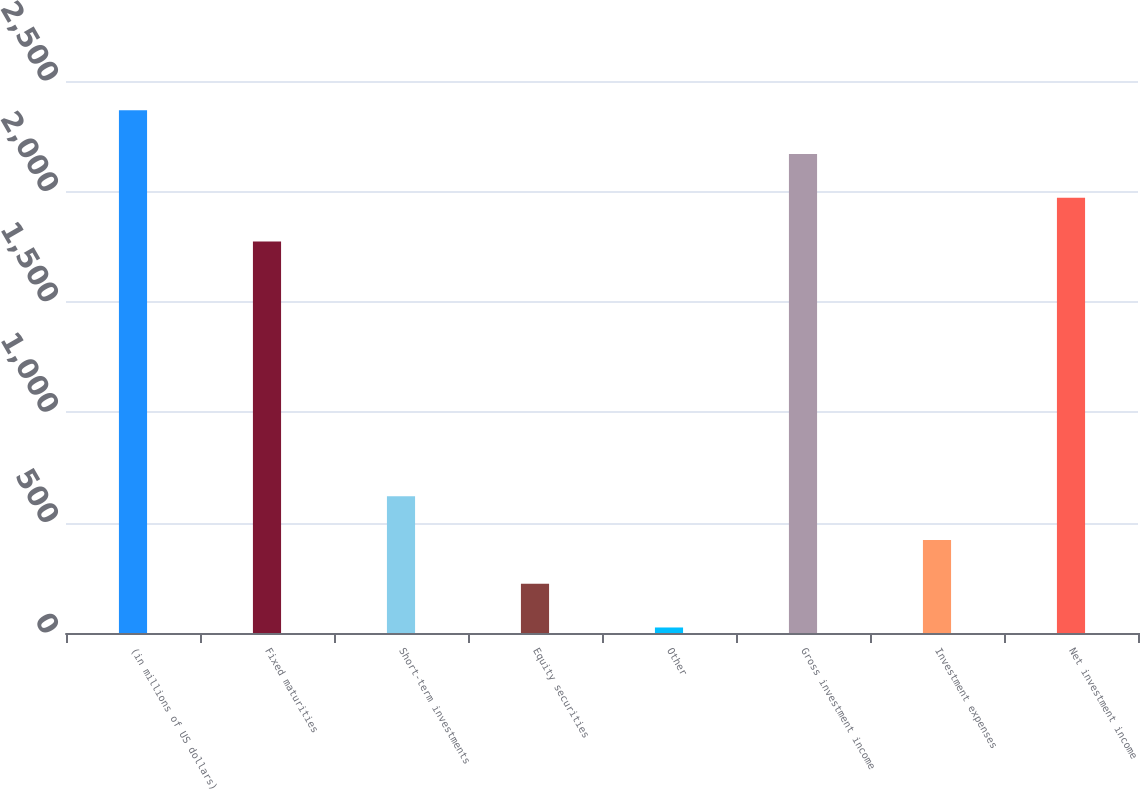Convert chart to OTSL. <chart><loc_0><loc_0><loc_500><loc_500><bar_chart><fcel>(in millions of US dollars)<fcel>Fixed maturities<fcel>Short-term investments<fcel>Equity securities<fcel>Other<fcel>Gross investment income<fcel>Investment expenses<fcel>Net investment income<nl><fcel>2367.6<fcel>1773<fcel>619.6<fcel>223.2<fcel>25<fcel>2169.4<fcel>421.4<fcel>1971.2<nl></chart> 